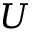Convert formula to latex. <formula><loc_0><loc_0><loc_500><loc_500>U</formula> 